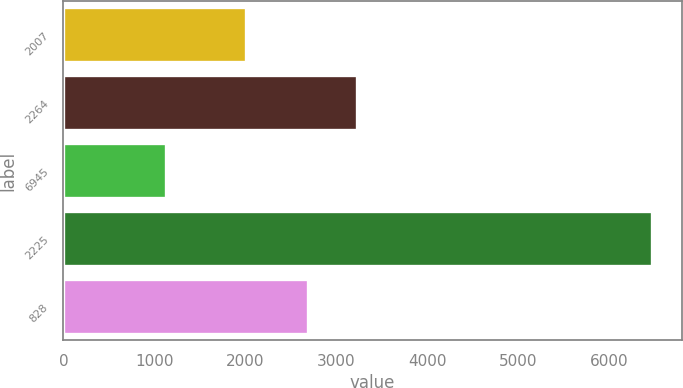Convert chart. <chart><loc_0><loc_0><loc_500><loc_500><bar_chart><fcel>2007<fcel>2264<fcel>6945<fcel>2225<fcel>828<nl><fcel>2005<fcel>3224<fcel>1133<fcel>6473<fcel>2690<nl></chart> 